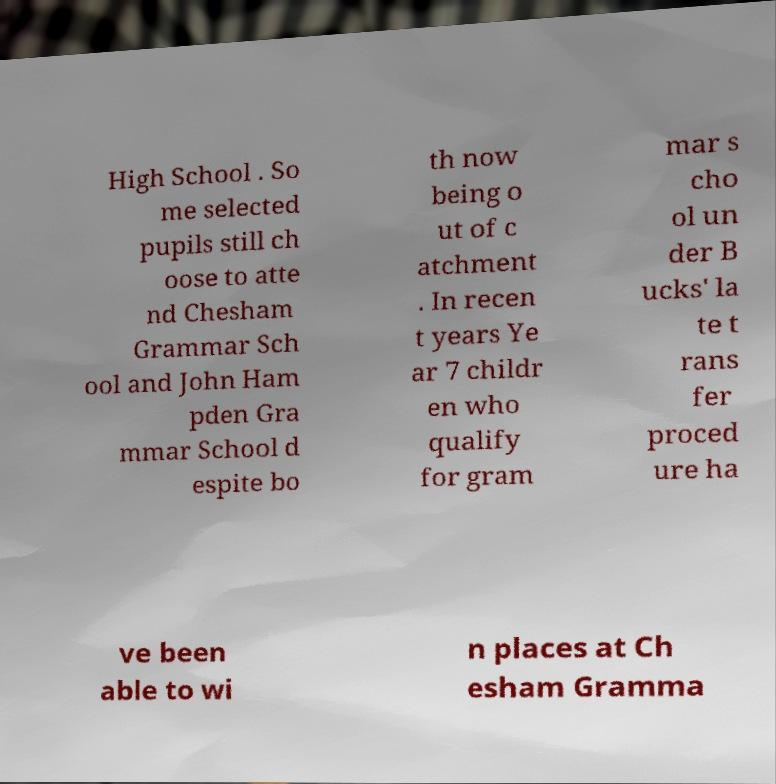Can you read and provide the text displayed in the image?This photo seems to have some interesting text. Can you extract and type it out for me? High School . So me selected pupils still ch oose to atte nd Chesham Grammar Sch ool and John Ham pden Gra mmar School d espite bo th now being o ut of c atchment . In recen t years Ye ar 7 childr en who qualify for gram mar s cho ol un der B ucks' la te t rans fer proced ure ha ve been able to wi n places at Ch esham Gramma 